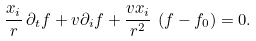<formula> <loc_0><loc_0><loc_500><loc_500>\frac { x _ { i } } { r } \, \partial _ { t } f + v \partial _ { i } f + \frac { v x _ { i } } { r ^ { 2 } } \, \left ( f - f _ { 0 } \right ) = 0 .</formula> 